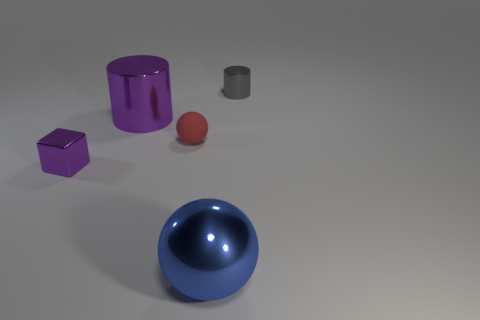Is there anything else that is the same material as the large purple cylinder?
Your response must be concise. Yes. Does the shiny cube have the same color as the cylinder that is right of the big ball?
Offer a terse response. No. What shape is the small gray object?
Make the answer very short. Cylinder. There is a purple metallic object behind the tiny thing to the left of the cylinder left of the small gray cylinder; what size is it?
Your answer should be very brief. Large. How many other objects are the same shape as the blue object?
Provide a short and direct response. 1. Do the big metallic thing right of the tiny sphere and the purple metal thing in front of the tiny ball have the same shape?
Your answer should be very brief. No. How many blocks are metallic things or small red rubber things?
Give a very brief answer. 1. There is a tiny thing that is left of the cylinder that is in front of the small object that is behind the tiny red matte thing; what is its material?
Give a very brief answer. Metal. What number of other objects are there of the same size as the matte object?
Provide a succinct answer. 2. What is the size of the cube that is the same color as the large cylinder?
Provide a succinct answer. Small. 